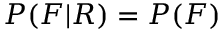<formula> <loc_0><loc_0><loc_500><loc_500>P ( F | R ) = P ( F )</formula> 